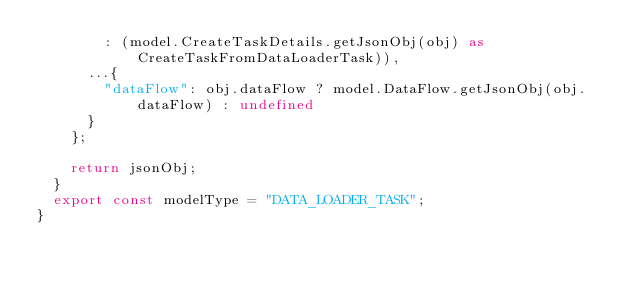<code> <loc_0><loc_0><loc_500><loc_500><_TypeScript_>        : (model.CreateTaskDetails.getJsonObj(obj) as CreateTaskFromDataLoaderTask)),
      ...{
        "dataFlow": obj.dataFlow ? model.DataFlow.getJsonObj(obj.dataFlow) : undefined
      }
    };

    return jsonObj;
  }
  export const modelType = "DATA_LOADER_TASK";
}
</code> 